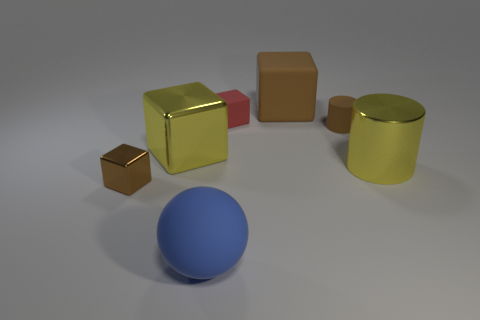Subtract 1 cubes. How many cubes are left? 3 Add 2 blocks. How many objects exist? 9 Subtract all cubes. How many objects are left? 3 Add 2 tiny rubber things. How many tiny rubber things exist? 4 Subtract 0 purple cylinders. How many objects are left? 7 Subtract all large purple rubber things. Subtract all spheres. How many objects are left? 6 Add 1 brown shiny cubes. How many brown shiny cubes are left? 2 